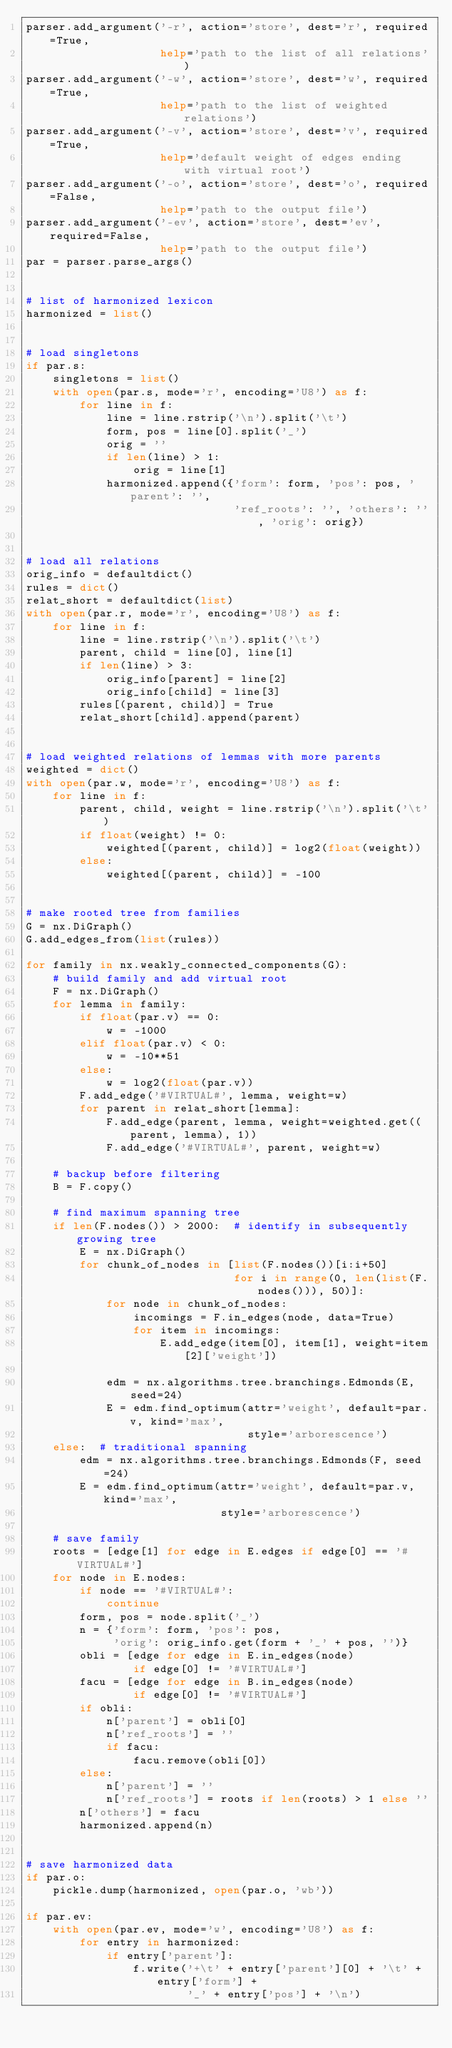<code> <loc_0><loc_0><loc_500><loc_500><_Python_>parser.add_argument('-r', action='store', dest='r', required=True,
                    help='path to the list of all relations')
parser.add_argument('-w', action='store', dest='w', required=True,
                    help='path to the list of weighted relations')
parser.add_argument('-v', action='store', dest='v', required=True,
                    help='default weight of edges ending with virtual root')
parser.add_argument('-o', action='store', dest='o', required=False,
                    help='path to the output file')
parser.add_argument('-ev', action='store', dest='ev', required=False,
                    help='path to the output file')
par = parser.parse_args()


# list of harmonized lexicon
harmonized = list()


# load singletons
if par.s:
    singletons = list()
    with open(par.s, mode='r', encoding='U8') as f:
        for line in f:
            line = line.rstrip('\n').split('\t')
            form, pos = line[0].split('_')
            orig = ''
            if len(line) > 1:
                orig = line[1]
            harmonized.append({'form': form, 'pos': pos, 'parent': '',
                               'ref_roots': '', 'others': '', 'orig': orig})


# load all relations
orig_info = defaultdict()
rules = dict()
relat_short = defaultdict(list)
with open(par.r, mode='r', encoding='U8') as f:
    for line in f:
        line = line.rstrip('\n').split('\t')
        parent, child = line[0], line[1]
        if len(line) > 3:
            orig_info[parent] = line[2]
            orig_info[child] = line[3]
        rules[(parent, child)] = True
        relat_short[child].append(parent)


# load weighted relations of lemmas with more parents
weighted = dict()
with open(par.w, mode='r', encoding='U8') as f:
    for line in f:
        parent, child, weight = line.rstrip('\n').split('\t')
        if float(weight) != 0:
            weighted[(parent, child)] = log2(float(weight))
        else:
            weighted[(parent, child)] = -100


# make rooted tree from families
G = nx.DiGraph()
G.add_edges_from(list(rules))

for family in nx.weakly_connected_components(G):
    # build family and add virtual root
    F = nx.DiGraph()
    for lemma in family:
        if float(par.v) == 0:
            w = -1000
        elif float(par.v) < 0:
            w = -10**51
        else:
            w = log2(float(par.v))
        F.add_edge('#VIRTUAL#', lemma, weight=w)
        for parent in relat_short[lemma]:
            F.add_edge(parent, lemma, weight=weighted.get((parent, lemma), 1))
            F.add_edge('#VIRTUAL#', parent, weight=w)

    # backup before filtering
    B = F.copy()

    # find maximum spanning tree
    if len(F.nodes()) > 2000:  # identify in subsequently growing tree
        E = nx.DiGraph()
        for chunk_of_nodes in [list(F.nodes())[i:i+50]
                               for i in range(0, len(list(F.nodes())), 50)]:
            for node in chunk_of_nodes:
                incomings = F.in_edges(node, data=True)
                for item in incomings:
                    E.add_edge(item[0], item[1], weight=item[2]['weight'])

            edm = nx.algorithms.tree.branchings.Edmonds(E, seed=24)
            E = edm.find_optimum(attr='weight', default=par.v, kind='max',
                                 style='arborescence')
    else:  # traditional spanning
        edm = nx.algorithms.tree.branchings.Edmonds(F, seed=24)
        E = edm.find_optimum(attr='weight', default=par.v, kind='max',
                             style='arborescence')

    # save family
    roots = [edge[1] for edge in E.edges if edge[0] == '#VIRTUAL#']
    for node in E.nodes:
        if node == '#VIRTUAL#':
            continue
        form, pos = node.split('_')
        n = {'form': form, 'pos': pos,
             'orig': orig_info.get(form + '_' + pos, '')}
        obli = [edge for edge in E.in_edges(node)
                if edge[0] != '#VIRTUAL#']
        facu = [edge for edge in B.in_edges(node)
                if edge[0] != '#VIRTUAL#']
        if obli:
            n['parent'] = obli[0]
            n['ref_roots'] = ''
            if facu:
                facu.remove(obli[0])
        else:
            n['parent'] = ''
            n['ref_roots'] = roots if len(roots) > 1 else ''
        n['others'] = facu
        harmonized.append(n)


# save harmonized data
if par.o:
    pickle.dump(harmonized, open(par.o, 'wb'))

if par.ev:
    with open(par.ev, mode='w', encoding='U8') as f:
        for entry in harmonized:
            if entry['parent']:
                f.write('+\t' + entry['parent'][0] + '\t' + entry['form'] +
                        '_' + entry['pos'] + '\n')
</code> 